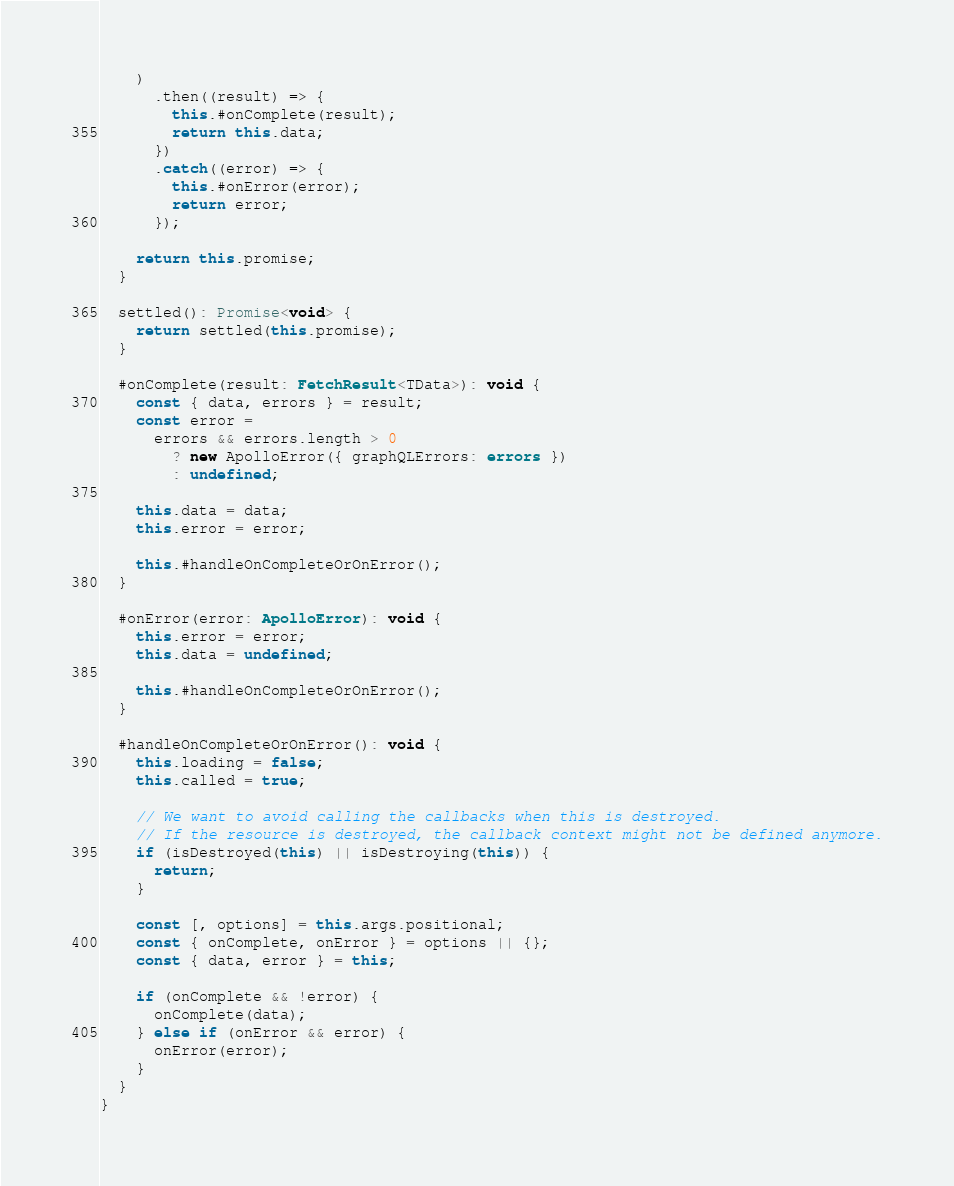<code> <loc_0><loc_0><loc_500><loc_500><_TypeScript_>    )
      .then((result) => {
        this.#onComplete(result);
        return this.data;
      })
      .catch((error) => {
        this.#onError(error);
        return error;
      });

    return this.promise;
  }

  settled(): Promise<void> {
    return settled(this.promise);
  }

  #onComplete(result: FetchResult<TData>): void {
    const { data, errors } = result;
    const error =
      errors && errors.length > 0
        ? new ApolloError({ graphQLErrors: errors })
        : undefined;

    this.data = data;
    this.error = error;

    this.#handleOnCompleteOrOnError();
  }

  #onError(error: ApolloError): void {
    this.error = error;
    this.data = undefined;

    this.#handleOnCompleteOrOnError();
  }

  #handleOnCompleteOrOnError(): void {
    this.loading = false;
    this.called = true;

    // We want to avoid calling the callbacks when this is destroyed.
    // If the resource is destroyed, the callback context might not be defined anymore.
    if (isDestroyed(this) || isDestroying(this)) {
      return;
    }

    const [, options] = this.args.positional;
    const { onComplete, onError } = options || {};
    const { data, error } = this;

    if (onComplete && !error) {
      onComplete(data);
    } else if (onError && error) {
      onError(error);
    }
  }
}
</code> 